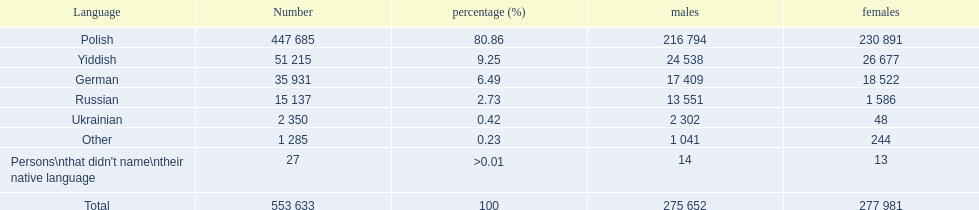What was the top percentage of a specific language spoken by the plock governorate? 80.86. What language was spoken by 80.86 percent of the persons? Polish. 